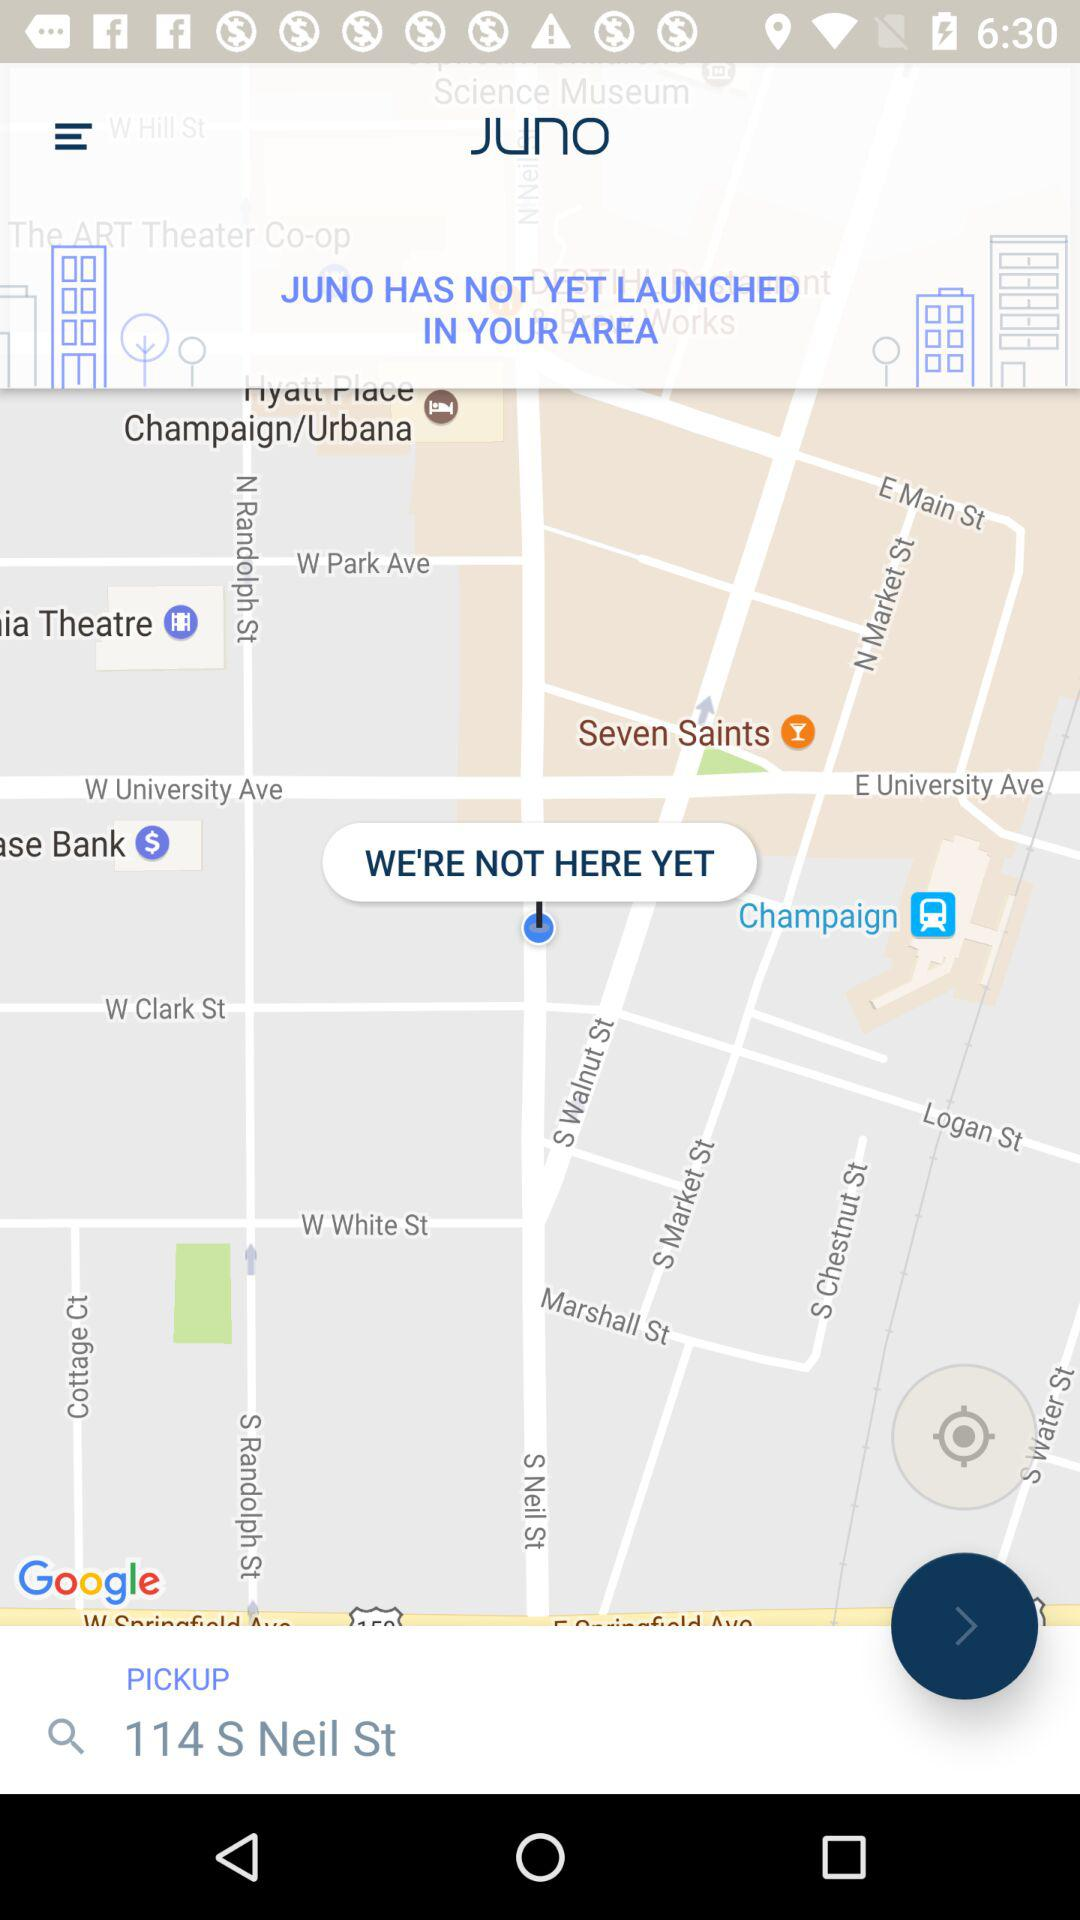What is the input given in the search bar for pickup? The given input in the search bar is "114 S Neil St". 